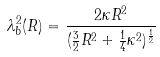Convert formula to latex. <formula><loc_0><loc_0><loc_500><loc_500>\lambda ^ { 2 } _ { b } ( R ) = \frac { 2 \kappa R ^ { 2 } } { ( \frac { 3 } { 2 } R ^ { 2 } + \frac { 1 } { 4 } \kappa ^ { 2 } ) ^ { \frac { 1 } { 2 } } }</formula> 